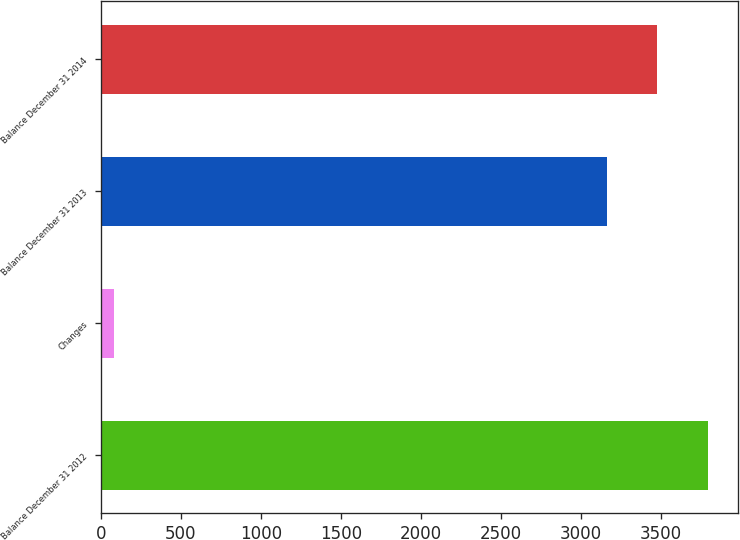Convert chart to OTSL. <chart><loc_0><loc_0><loc_500><loc_500><bar_chart><fcel>Balance December 31 2012<fcel>Changes<fcel>Balance December 31 2013<fcel>Balance December 31 2014<nl><fcel>3792<fcel>81<fcel>3160<fcel>3476<nl></chart> 